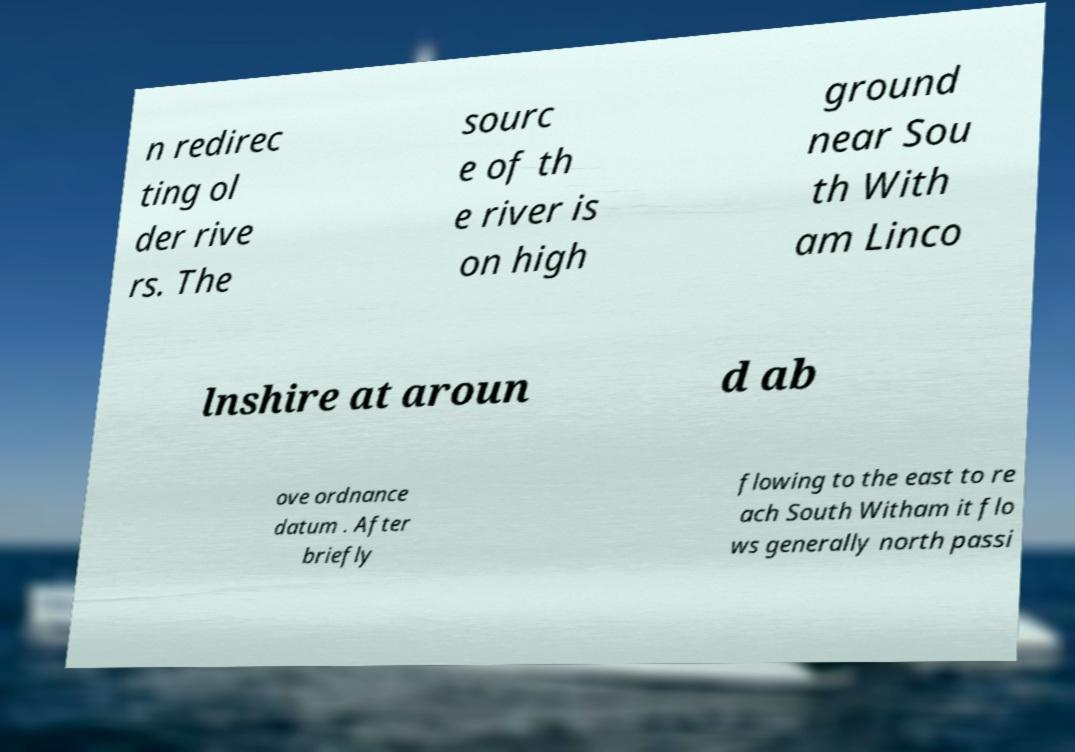Please read and relay the text visible in this image. What does it say? n redirec ting ol der rive rs. The sourc e of th e river is on high ground near Sou th With am Linco lnshire at aroun d ab ove ordnance datum . After briefly flowing to the east to re ach South Witham it flo ws generally north passi 